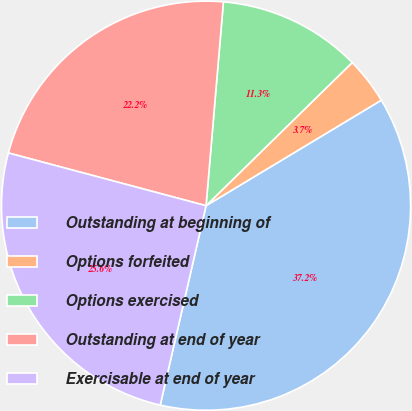Convert chart. <chart><loc_0><loc_0><loc_500><loc_500><pie_chart><fcel>Outstanding at beginning of<fcel>Options forfeited<fcel>Options exercised<fcel>Outstanding at end of year<fcel>Exercisable at end of year<nl><fcel>37.22%<fcel>3.71%<fcel>11.31%<fcel>22.2%<fcel>25.55%<nl></chart> 